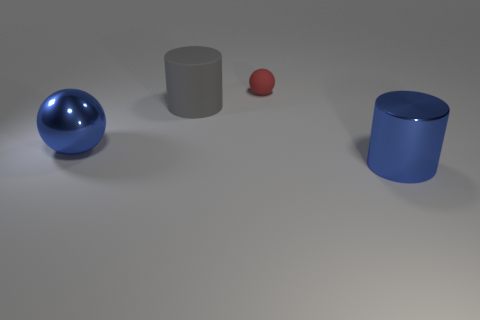Can you describe the textures of the objects? Certainly. The large blue metallic sphere has a reflective texture that shows a clear environment reflection, suggesting a smooth, polished surface. The big gray cylinder and the ground have a matte texture, lacking any reflection, which indicates a non-glossy, rougher surface. The small red sphere has a slight sheen, hinting at a somewhat glossy texture that is less reflective than the blue sphere but smoother than the gray cylinder.  Could these objects serve a functional purpose, or are they likely for aesthetic display? These objects seem to be more for aesthetic purposes or for a demonstration, as they are arranged deliberately with no apparent functional relation to each other. If they were functional, they'd likely show some indications of wear, utility features, or connection points, which are not present in this scene. 